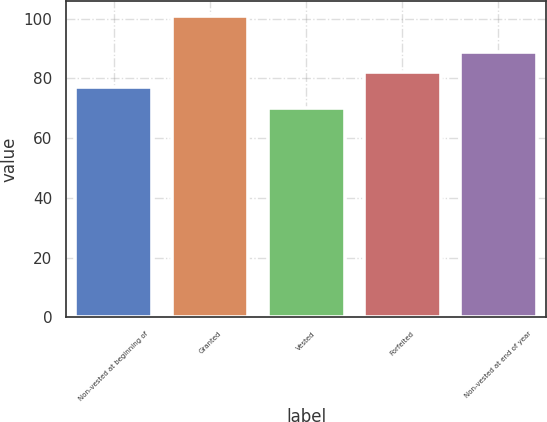Convert chart. <chart><loc_0><loc_0><loc_500><loc_500><bar_chart><fcel>Non-vested at beginning of<fcel>Granted<fcel>Vested<fcel>Forfeited<fcel>Non-vested at end of year<nl><fcel>77<fcel>101<fcel>70<fcel>82<fcel>89<nl></chart> 